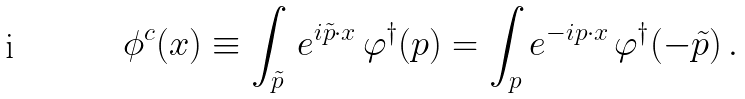<formula> <loc_0><loc_0><loc_500><loc_500>\phi ^ { c } ( x ) \equiv \int _ { \tilde { p } } \, e ^ { i \tilde { p } \cdot x } \, \varphi ^ { \dagger } ( p ) = \int _ { p } e ^ { - i p \cdot x } \, \varphi ^ { \dagger } ( - \tilde { p } ) \, .</formula> 